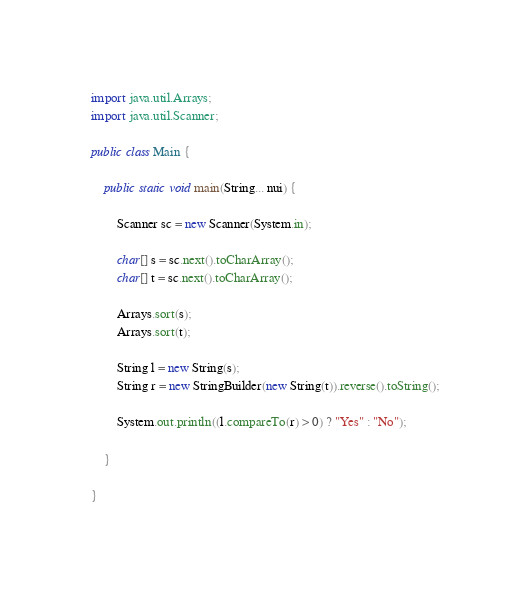<code> <loc_0><loc_0><loc_500><loc_500><_Java_>import java.util.Arrays;
import java.util.Scanner;

public class Main {

	public static void main(String... nui) {
		
		Scanner sc = new Scanner(System.in);

		char[] s = sc.next().toCharArray();
		char[] t = sc.next().toCharArray();
		
		Arrays.sort(s);
		Arrays.sort(t);
		
		String l = new String(s);
		String r = new StringBuilder(new String(t)).reverse().toString();
		
		System.out.println((l.compareTo(r) > 0) ? "Yes" : "No");
		
	}

}
</code> 